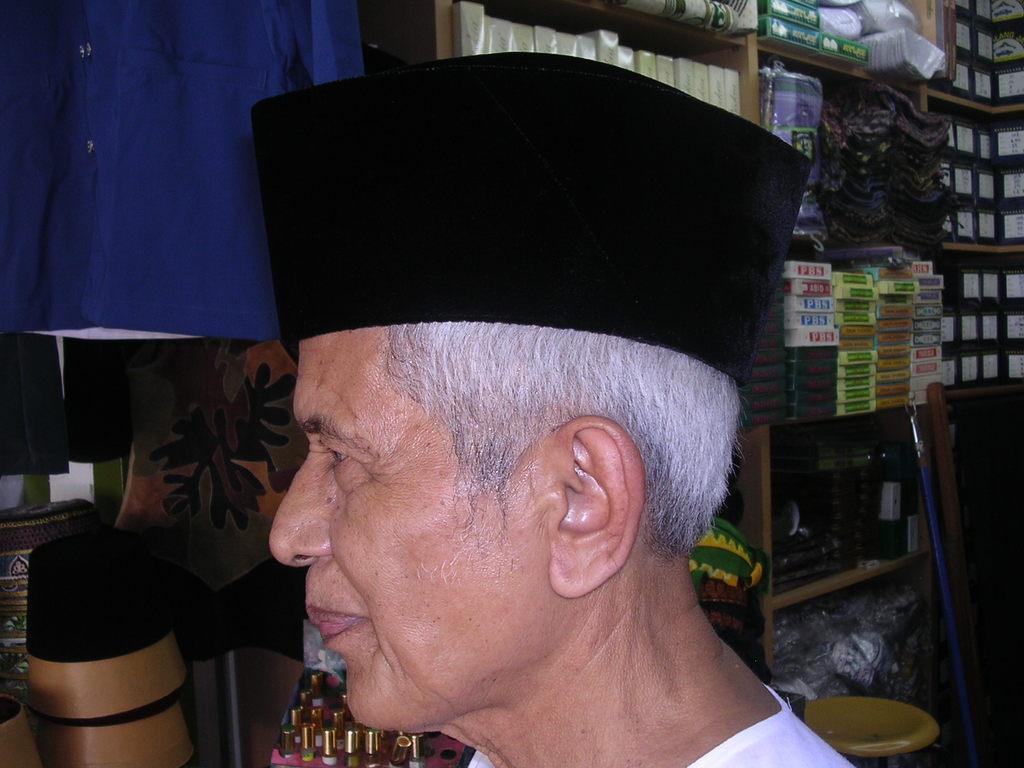Could you give a brief overview of what you see in this image? In this image I can see a person wearing white colored dress and black colored hat. In the background I can see the blue colored cloth, few racks with few boxes and few objects in it, a blue colored rod and few other objects. 